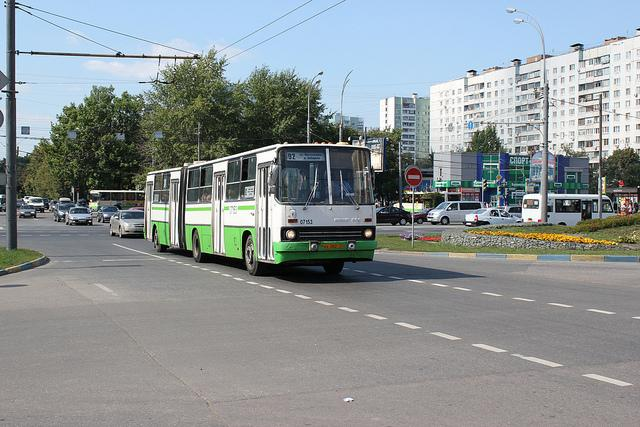What type setting is this roadway located in? Please explain your reasoning. urban. There are buildings and streets clustered together in a city like setting. 